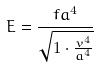Convert formula to latex. <formula><loc_0><loc_0><loc_500><loc_500>E = \frac { f a ^ { 4 } } { \sqrt { 1 \cdot \frac { v ^ { 4 } } { a ^ { 4 } } } }</formula> 